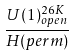Convert formula to latex. <formula><loc_0><loc_0><loc_500><loc_500>\frac { U ( 1 ) _ { o p e n } ^ { 2 6 K } } { H ( p e r m ) }</formula> 